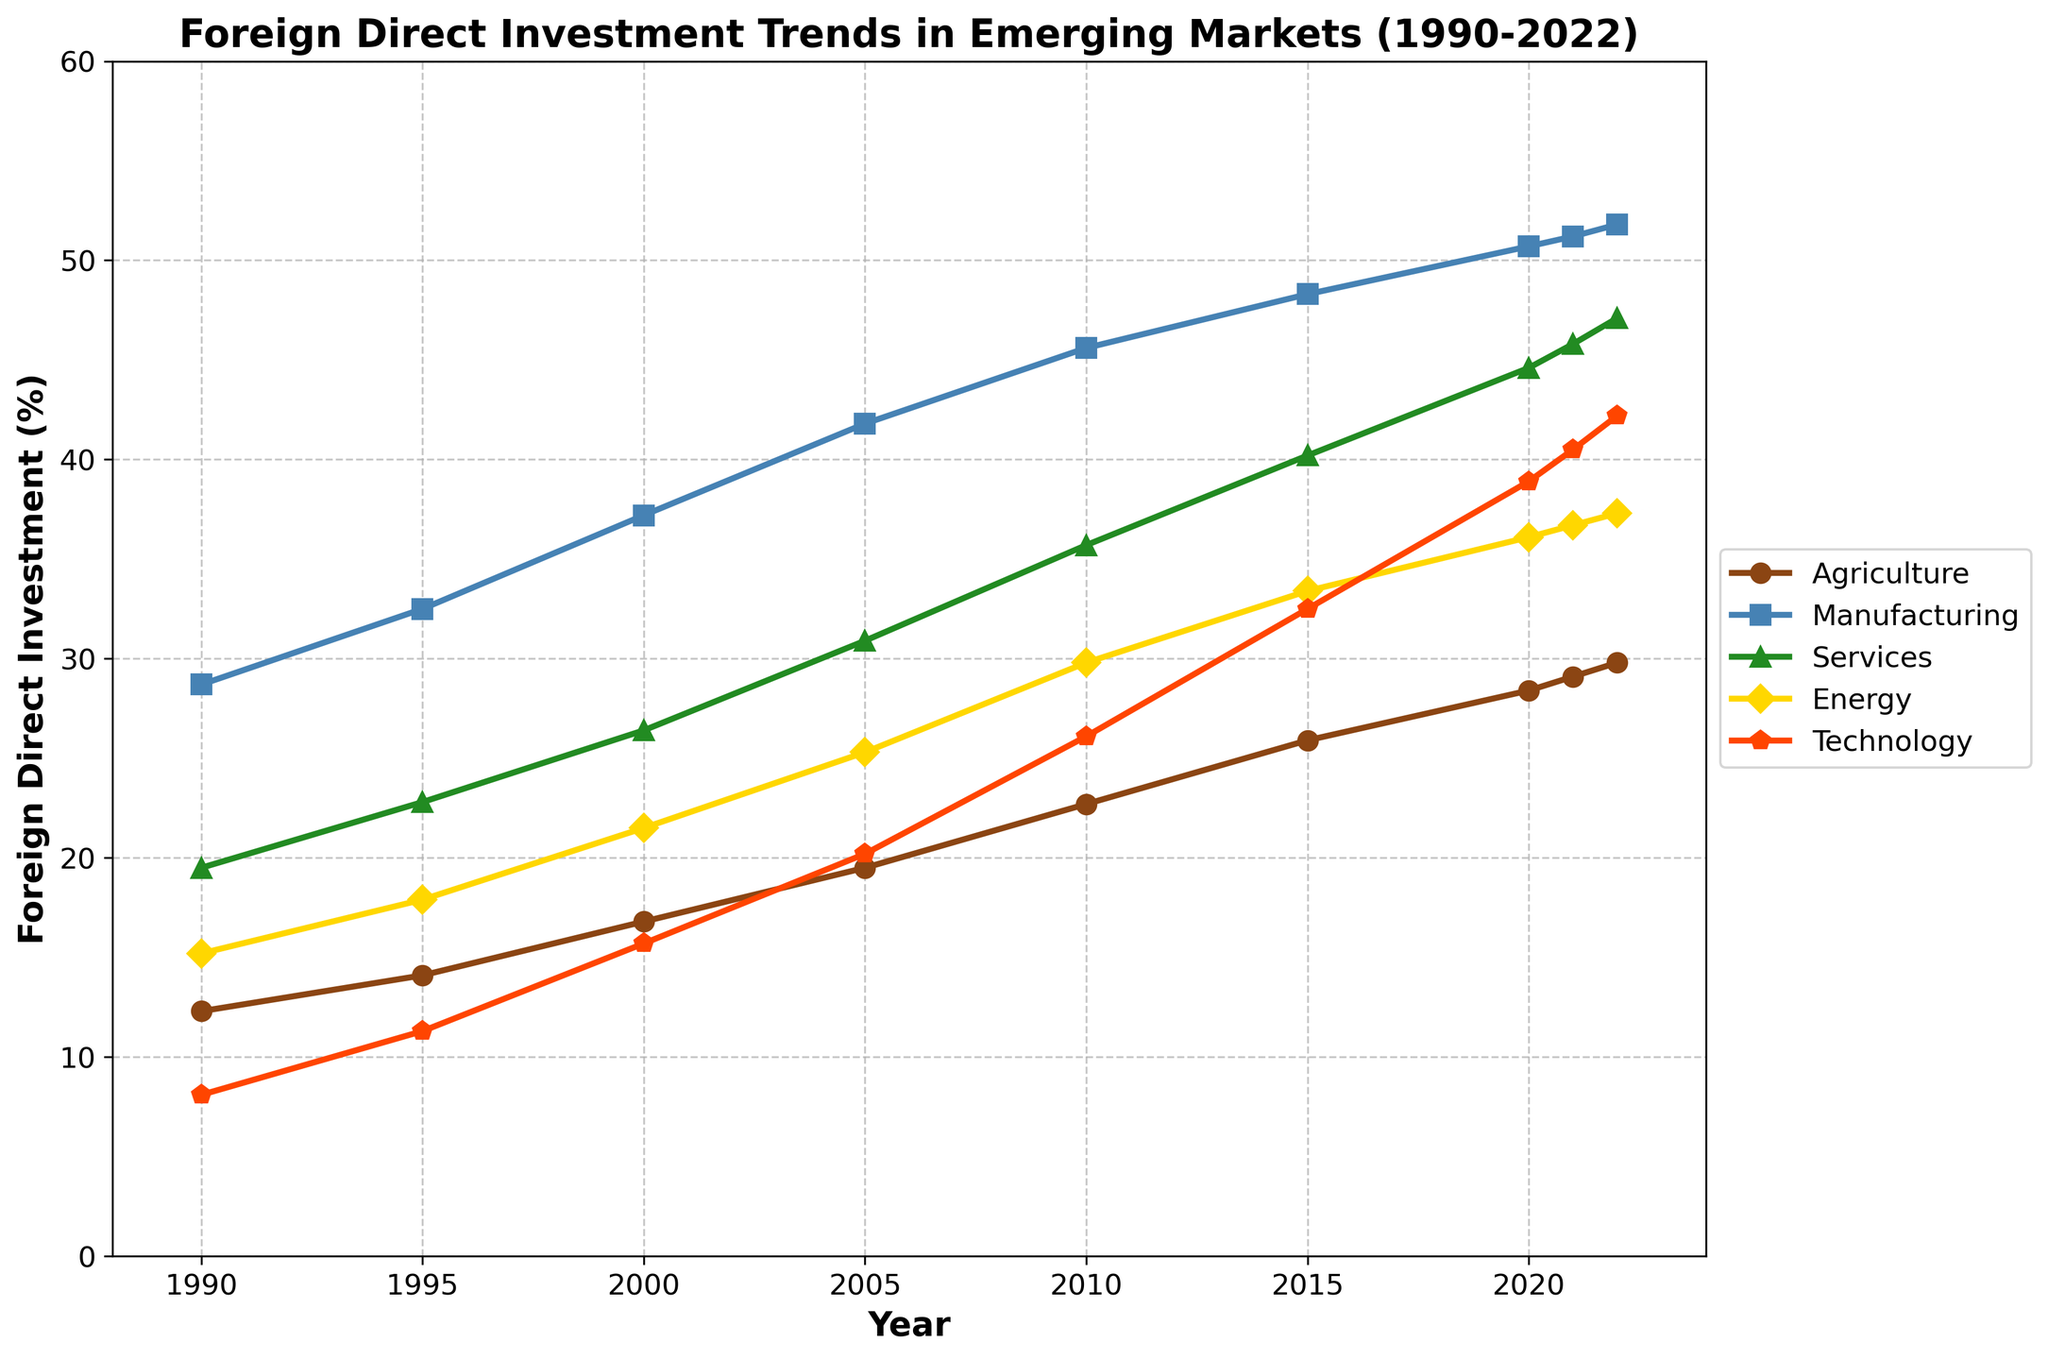How has the trend of Foreign Direct Investment (FDI) in the Technology sector changed from 1990 to 2022? From 1990 to 2022, the FDI in the Technology sector shows a steady increase. Starting at 8.1% in 1990, it rises year by year, reaching 42.2% in 2022. The trend line is consistently upward, indicating growing investment in the Technology sector over the period.
Answer: Increased steadily Which sector observed the highest growth in Foreign Direct Investment from 1990 to 2022? To determine the highest growth, calculate the difference in FDI for each sector between 1990 and 2022. Agriculture grew by 29.8 - 12.3 = 17.5%, Manufacturing by 51.8 - 28.7 = 23.1%, Services by 47.1 - 19.5 = 27.6%, Energy by 37.3 - 15.2 = 22.1%, and Technology by 42.2 - 8.1 = 34.1%. The Technology sector has the highest growth.
Answer: Technology In what year did the Services sector surpass 40% in Foreign Direct Investment? From the figure, locate the Services sector line and identify the year where it crosses the 40% mark. The Services sector surpasses 40% in 2015.
Answer: 2015 Among the sectors, which has the least fluctuation in the Foreign Direct Investment trend? Least fluctuation can be interpreted as the smallest variability in the investment percentage. By visually examining the trends, Manufacturing shows a steady increase without sharp changes, indicating the least fluctuation.
Answer: Manufacturing What is the total Foreign Direct Investment percentage of all sectors combined in 2020? Sum the values of all sectors in 2020: Agriculture (28.4), Manufacturing (50.7), Services (44.6), Energy (36.1), Technology (38.9). Total is 28.4 + 50.7 + 44.6 + 36.1 + 38.9 = 198.7%.
Answer: 198.7% Which two sectors had the closest Foreign Direct Investment percentages in 2022? Compare the 2022 values: Agriculture (29.8), Manufacturing (51.8), Services (47.1), Energy (37.3), Technology (42.2). Services and Technology are closest with 47.1% and 42.2%, respectively.
Answer: Services and Technology In which year did the Foreign Direct Investment in Energy sector first exceed 30%? Find the point where Energy first crosses 30% on the figure. This happened in 2010.
Answer: 2010 What is the average Foreign Direct Investment percentage in the Agriculture sector across the years 1990, 2000, 2010, and 2020? Calculate the average of Agriculture FDI percentages from these years: (12.3 in 1990, 16.8 in 2000, 22.7 in 2010, 28.4 in 2020). Average is (12.3 + 16.8 + 22.7 + 28.4) / 4 = 20.05%.
Answer: 20.05% By how much did the Foreign Direct Investment in the Manufacturing sector increase between 2005 and 2022? Calculate the difference in percentages for Manufacturing between 2005 and 2022: 51.8 - 41.8 = 10%.
Answer: 10% 